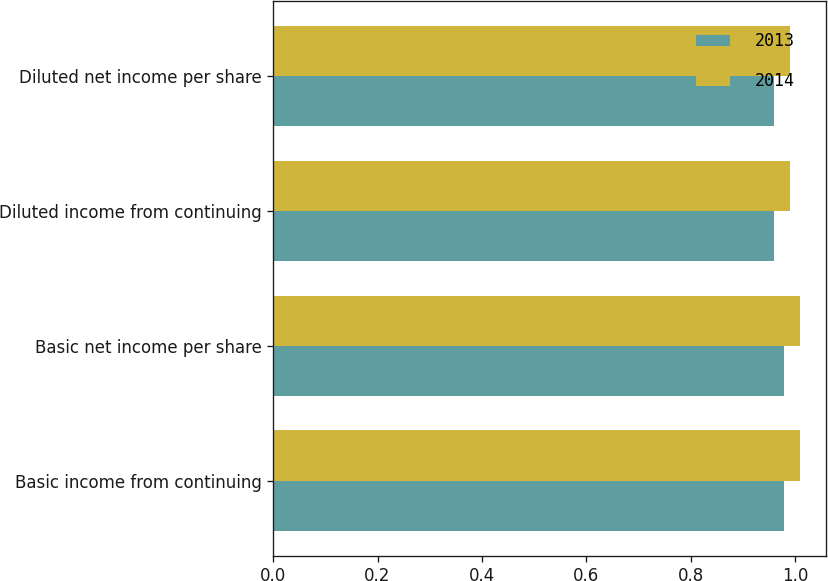Convert chart. <chart><loc_0><loc_0><loc_500><loc_500><stacked_bar_chart><ecel><fcel>Basic income from continuing<fcel>Basic net income per share<fcel>Diluted income from continuing<fcel>Diluted net income per share<nl><fcel>2013<fcel>0.98<fcel>0.98<fcel>0.96<fcel>0.96<nl><fcel>2014<fcel>1.01<fcel>1.01<fcel>0.99<fcel>0.99<nl></chart> 